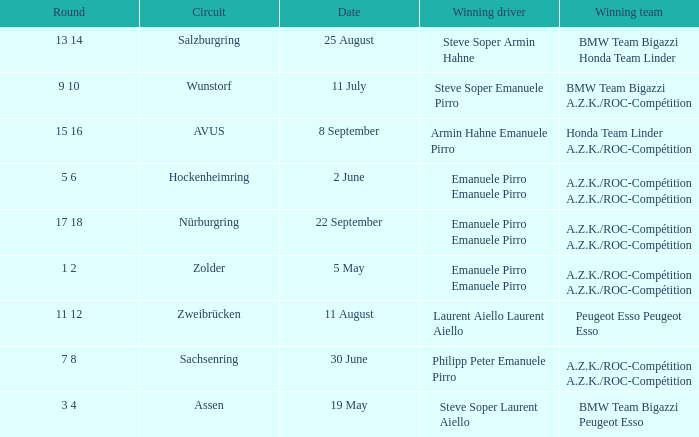Who is the winning driver of the race on 2 June with a.z.k./roc-compétition a.z.k./roc-compétition as the winning team? Emanuele Pirro Emanuele Pirro. 